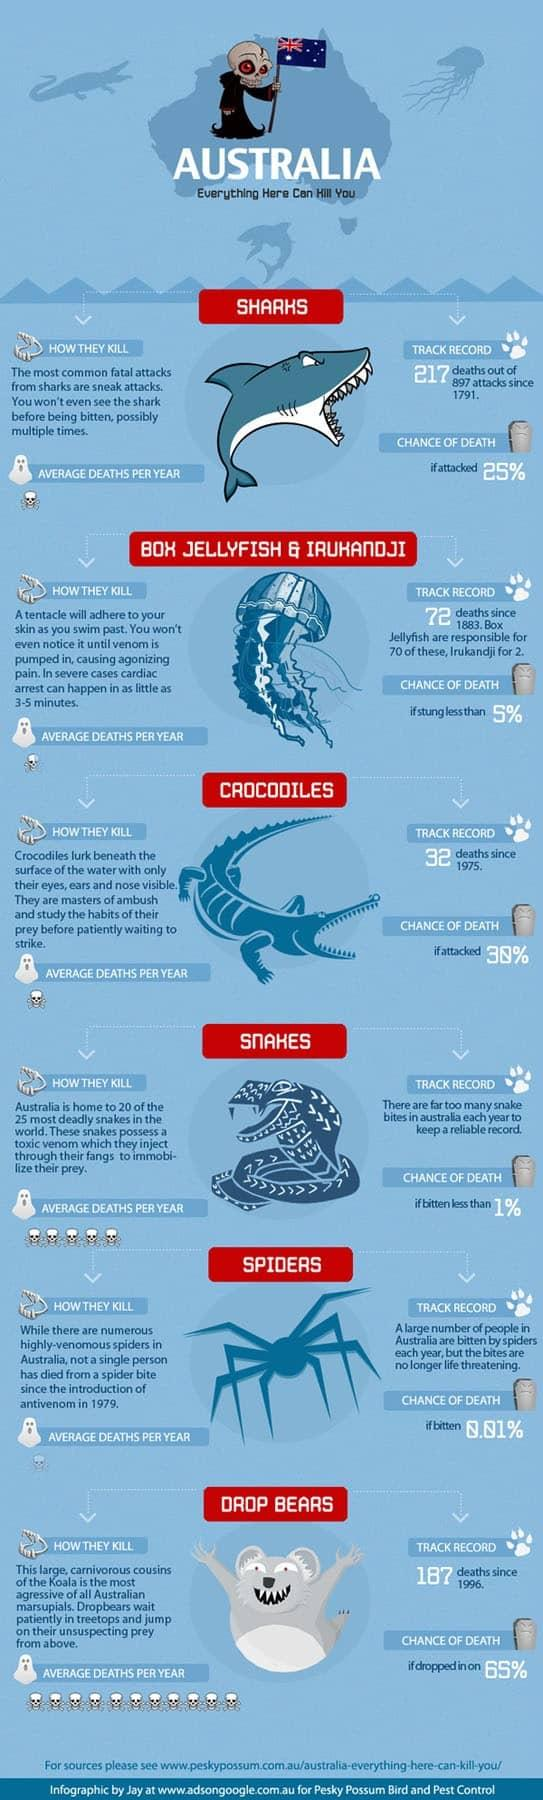Point out several critical features in this image. According to a recent estimate, an average of 5 deaths per year in Australia are caused by snake bites. Since 1996, the number of deaths caused by drop bears in Australia has been 187. It is highly unlikely that an individual will die as a result of being bitten by a snake in Australia, with the average chance of death being less than 1%. The chance of survival if dropped in by a drop bear is estimated to be 35%. The average number of deaths per year caused by crocodile attacks in Australia is 1. 